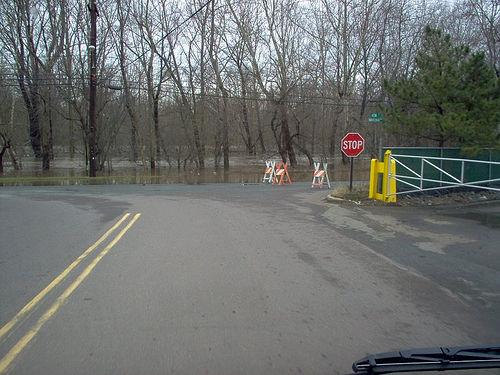What state is on the sign?
Give a very brief answer. None. Are there any children in this picture?
Keep it brief. No. What are the yellow lines called?
Quick response, please. Dividers. Why don't the trees have leaves?
Short answer required. Winter. Where is the stop sign?
Keep it brief. On right. 